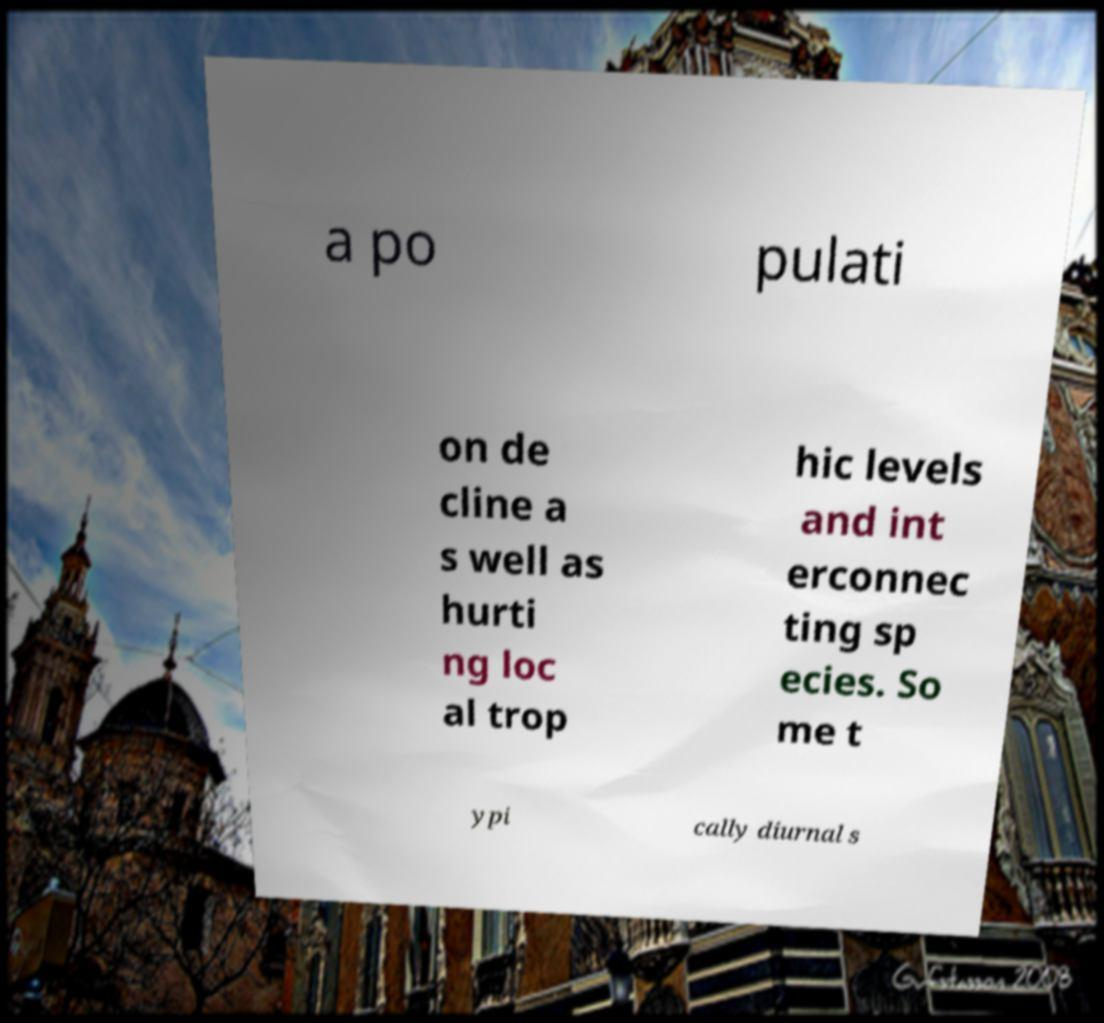I need the written content from this picture converted into text. Can you do that? a po pulati on de cline a s well as hurti ng loc al trop hic levels and int erconnec ting sp ecies. So me t ypi cally diurnal s 